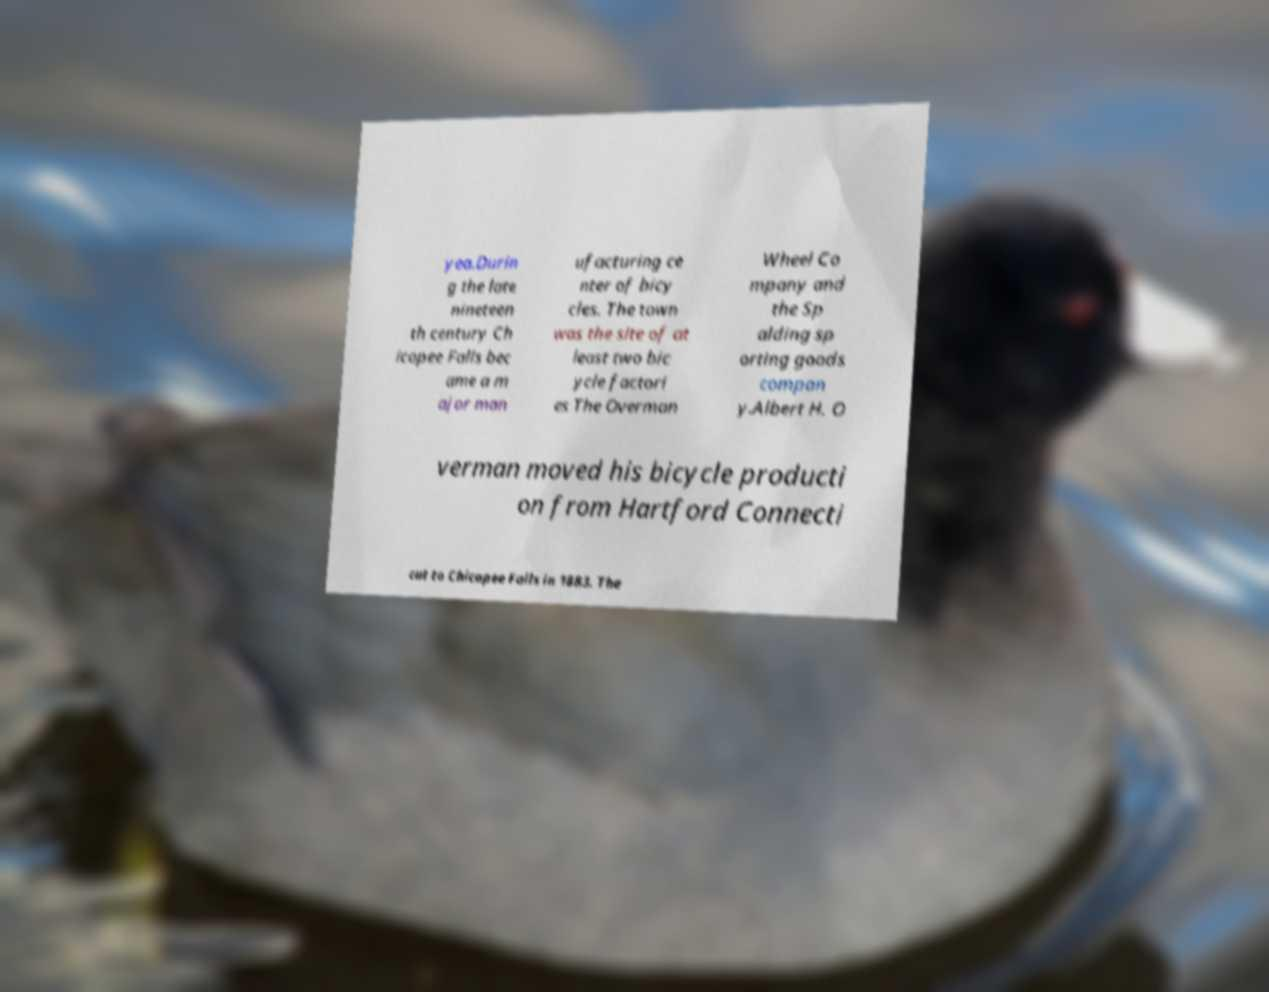Could you extract and type out the text from this image? yea.Durin g the late nineteen th century Ch icopee Falls bec ame a m ajor man ufacturing ce nter of bicy cles. The town was the site of at least two bic ycle factori es The Overman Wheel Co mpany and the Sp alding sp orting goods compan y.Albert H. O verman moved his bicycle producti on from Hartford Connecti cut to Chicopee Falls in 1883. The 